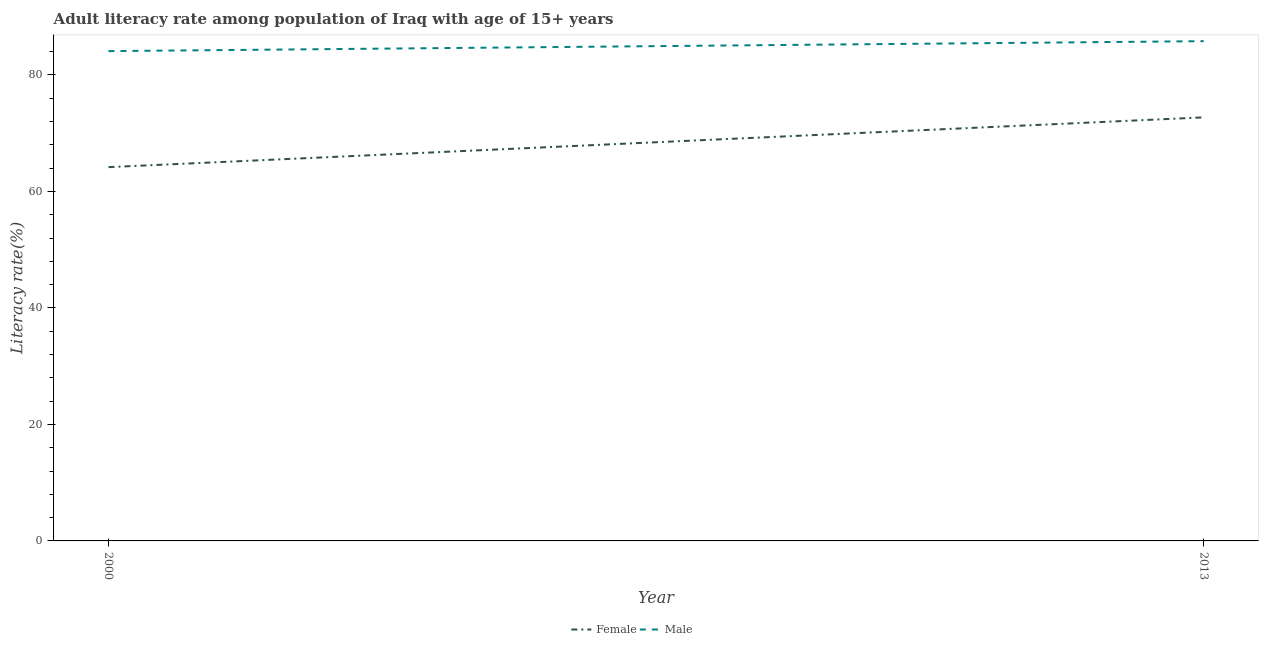How many different coloured lines are there?
Keep it short and to the point. 2. What is the female adult literacy rate in 2000?
Provide a succinct answer. 64.17. Across all years, what is the maximum male adult literacy rate?
Give a very brief answer. 85.8. Across all years, what is the minimum male adult literacy rate?
Keep it short and to the point. 84.09. In which year was the female adult literacy rate maximum?
Your answer should be compact. 2013. In which year was the female adult literacy rate minimum?
Ensure brevity in your answer.  2000. What is the total female adult literacy rate in the graph?
Make the answer very short. 136.88. What is the difference between the female adult literacy rate in 2000 and that in 2013?
Make the answer very short. -8.55. What is the difference between the female adult literacy rate in 2013 and the male adult literacy rate in 2000?
Provide a succinct answer. -11.37. What is the average male adult literacy rate per year?
Provide a succinct answer. 84.94. In the year 2013, what is the difference between the male adult literacy rate and female adult literacy rate?
Offer a terse response. 13.08. What is the ratio of the female adult literacy rate in 2000 to that in 2013?
Your answer should be very brief. 0.88. Does the male adult literacy rate monotonically increase over the years?
Make the answer very short. Yes. How many years are there in the graph?
Your answer should be very brief. 2. How are the legend labels stacked?
Make the answer very short. Horizontal. What is the title of the graph?
Provide a succinct answer. Adult literacy rate among population of Iraq with age of 15+ years. What is the label or title of the Y-axis?
Make the answer very short. Literacy rate(%). What is the Literacy rate(%) of Female in 2000?
Offer a terse response. 64.17. What is the Literacy rate(%) of Male in 2000?
Provide a short and direct response. 84.09. What is the Literacy rate(%) in Female in 2013?
Your answer should be very brief. 72.71. What is the Literacy rate(%) in Male in 2013?
Offer a terse response. 85.8. Across all years, what is the maximum Literacy rate(%) of Female?
Ensure brevity in your answer.  72.71. Across all years, what is the maximum Literacy rate(%) in Male?
Give a very brief answer. 85.8. Across all years, what is the minimum Literacy rate(%) in Female?
Ensure brevity in your answer.  64.17. Across all years, what is the minimum Literacy rate(%) in Male?
Make the answer very short. 84.09. What is the total Literacy rate(%) of Female in the graph?
Your response must be concise. 136.88. What is the total Literacy rate(%) in Male in the graph?
Make the answer very short. 169.88. What is the difference between the Literacy rate(%) in Female in 2000 and that in 2013?
Your answer should be compact. -8.55. What is the difference between the Literacy rate(%) in Male in 2000 and that in 2013?
Ensure brevity in your answer.  -1.71. What is the difference between the Literacy rate(%) of Female in 2000 and the Literacy rate(%) of Male in 2013?
Provide a succinct answer. -21.63. What is the average Literacy rate(%) in Female per year?
Your response must be concise. 68.44. What is the average Literacy rate(%) in Male per year?
Offer a terse response. 84.94. In the year 2000, what is the difference between the Literacy rate(%) of Female and Literacy rate(%) of Male?
Give a very brief answer. -19.92. In the year 2013, what is the difference between the Literacy rate(%) of Female and Literacy rate(%) of Male?
Provide a succinct answer. -13.08. What is the ratio of the Literacy rate(%) in Female in 2000 to that in 2013?
Make the answer very short. 0.88. What is the ratio of the Literacy rate(%) in Male in 2000 to that in 2013?
Ensure brevity in your answer.  0.98. What is the difference between the highest and the second highest Literacy rate(%) of Female?
Your answer should be very brief. 8.55. What is the difference between the highest and the second highest Literacy rate(%) of Male?
Your answer should be compact. 1.71. What is the difference between the highest and the lowest Literacy rate(%) in Female?
Make the answer very short. 8.55. What is the difference between the highest and the lowest Literacy rate(%) of Male?
Offer a very short reply. 1.71. 